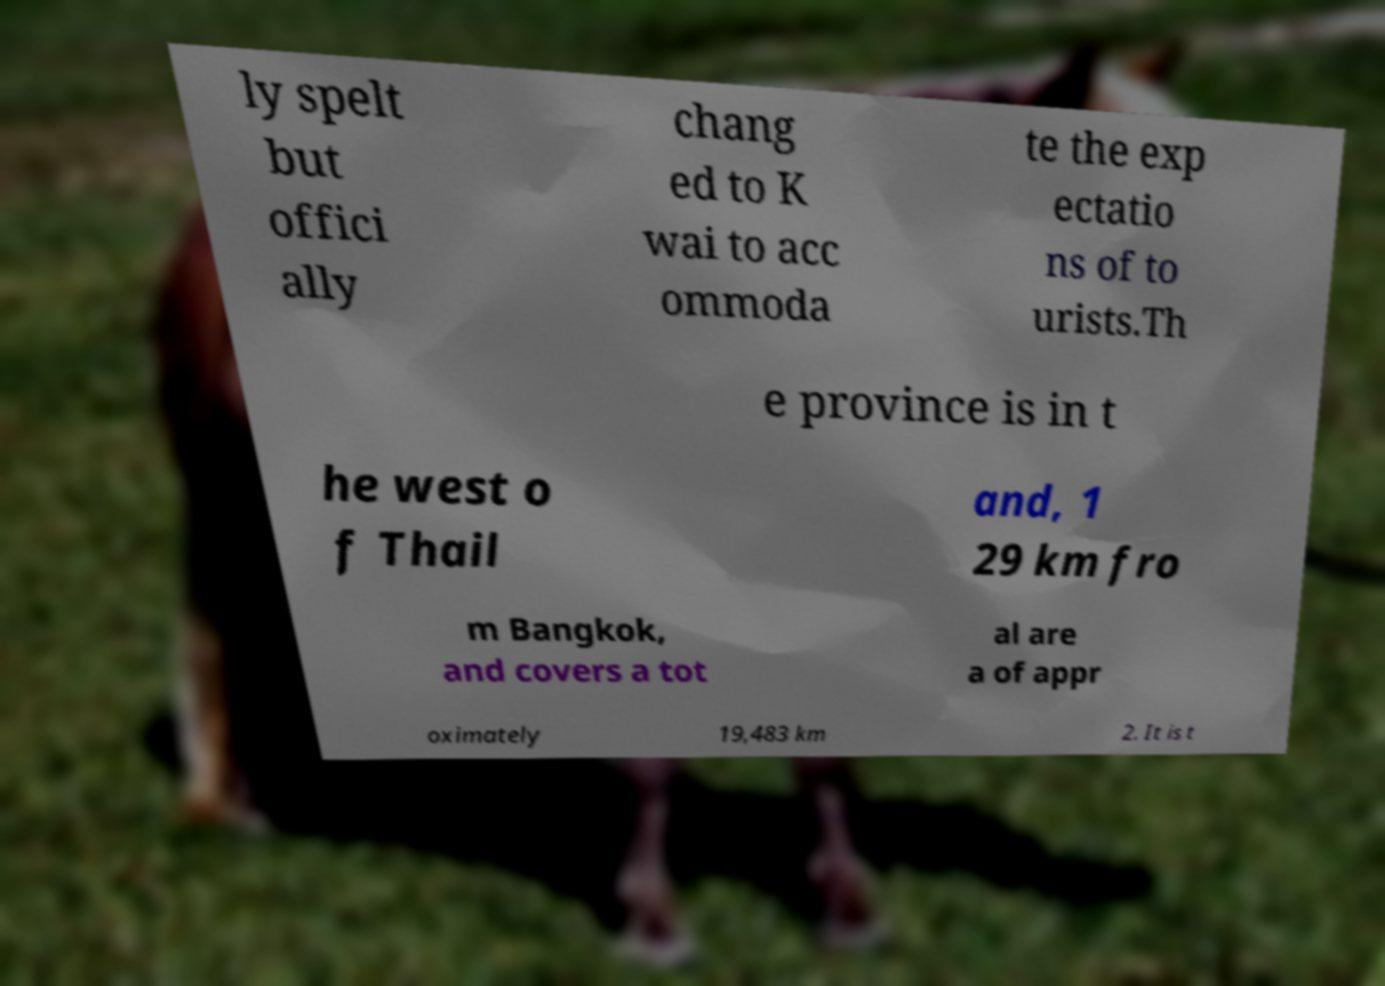Please read and relay the text visible in this image. What does it say? ly spelt but offici ally chang ed to K wai to acc ommoda te the exp ectatio ns of to urists.Th e province is in t he west o f Thail and, 1 29 km fro m Bangkok, and covers a tot al are a of appr oximately 19,483 km 2. It is t 